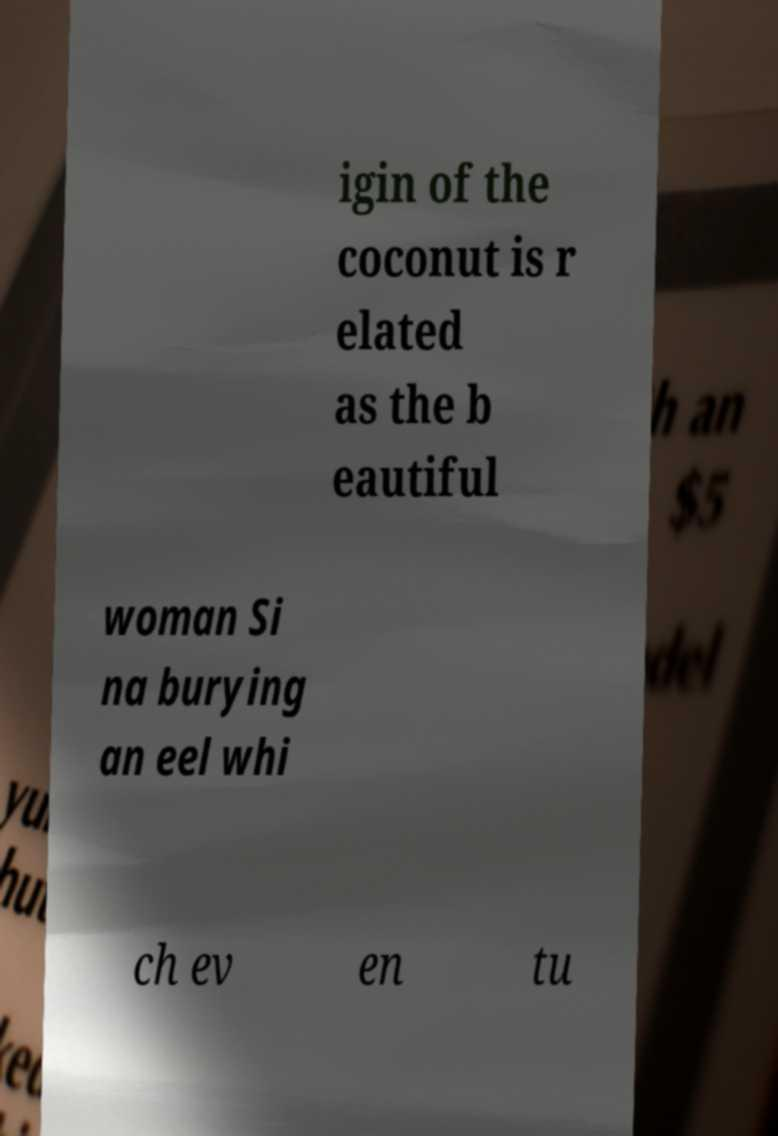What messages or text are displayed in this image? I need them in a readable, typed format. igin of the coconut is r elated as the b eautiful woman Si na burying an eel whi ch ev en tu 